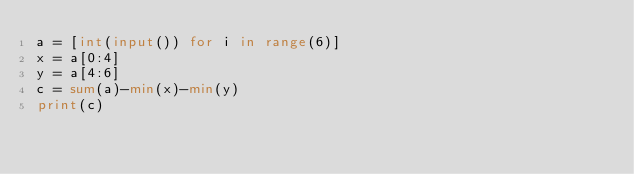Convert code to text. <code><loc_0><loc_0><loc_500><loc_500><_Python_>a = [int(input()) for i in range(6)]
x = a[0:4]
y = a[4:6]
c = sum(a)-min(x)-min(y)    
print(c)
</code> 